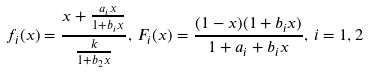<formula> <loc_0><loc_0><loc_500><loc_500>f _ { i } ( x ) = \frac { x + \frac { a _ { i } x } { 1 + b _ { i } x } } { \frac { k } { 1 + b _ { 2 } x } } , \, F _ { i } ( x ) = \frac { ( 1 - x ) ( 1 + b _ { i } x ) } { 1 + a _ { i } + b _ { i } x } , \, i = 1 , 2</formula> 